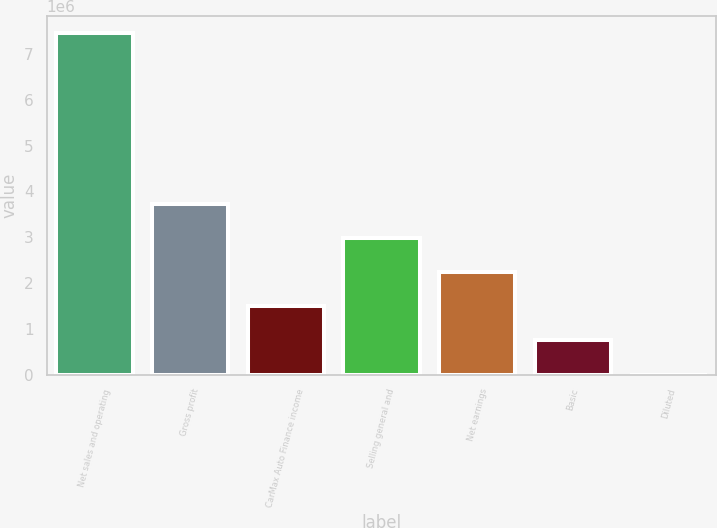Convert chart to OTSL. <chart><loc_0><loc_0><loc_500><loc_500><bar_chart><fcel>Net sales and operating<fcel>Gross profit<fcel>CarMax Auto Finance income<fcel>Selling general and<fcel>Net earnings<fcel>Basic<fcel>Diluted<nl><fcel>7.46566e+06<fcel>3.73283e+06<fcel>1.49313e+06<fcel>2.98626e+06<fcel>2.2397e+06<fcel>746566<fcel>0.92<nl></chart> 